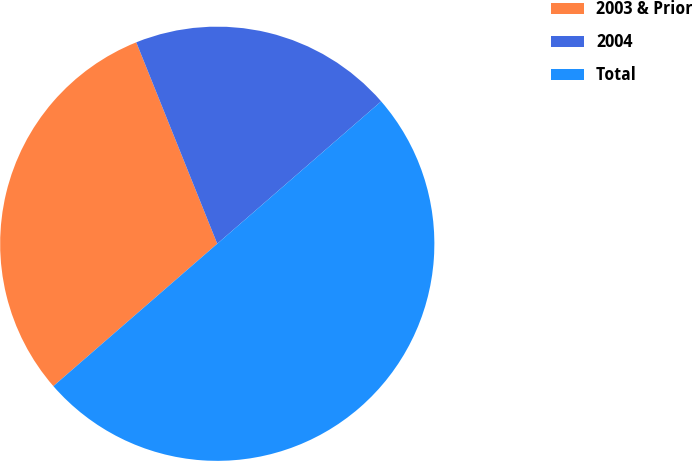Convert chart. <chart><loc_0><loc_0><loc_500><loc_500><pie_chart><fcel>2003 & Prior<fcel>2004<fcel>Total<nl><fcel>30.3%<fcel>19.7%<fcel>50.0%<nl></chart> 